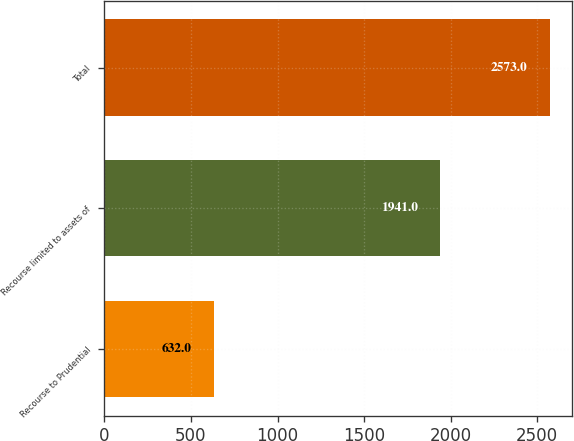<chart> <loc_0><loc_0><loc_500><loc_500><bar_chart><fcel>Recourse to Prudential<fcel>Recourse limited to assets of<fcel>Total<nl><fcel>632<fcel>1941<fcel>2573<nl></chart> 